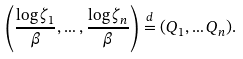<formula> <loc_0><loc_0><loc_500><loc_500>\left ( \frac { \log \zeta _ { 1 } } { \beta } , \dots , \frac { \log \zeta _ { n } } { \beta } \right ) \stackrel { d } { = } ( Q _ { 1 } , \dots Q _ { n } ) .</formula> 